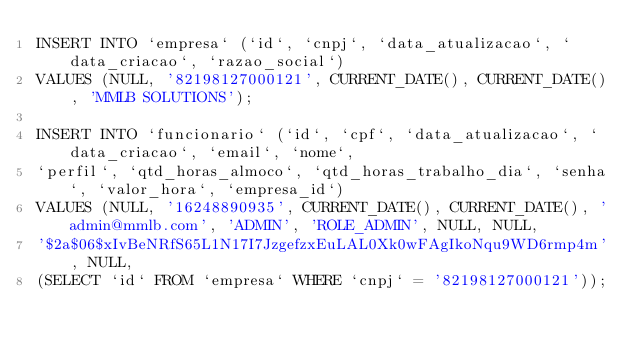<code> <loc_0><loc_0><loc_500><loc_500><_SQL_>INSERT INTO `empresa` (`id`, `cnpj`, `data_atualizacao`, `data_criacao`, `razao_social`) 
VALUES (NULL, '82198127000121', CURRENT_DATE(), CURRENT_DATE(), 'MMLB SOLUTIONS');

INSERT INTO `funcionario` (`id`, `cpf`, `data_atualizacao`, `data_criacao`, `email`, `nome`, 
`perfil`, `qtd_horas_almoco`, `qtd_horas_trabalho_dia`, `senha`, `valor_hora`, `empresa_id`) 
VALUES (NULL, '16248890935', CURRENT_DATE(), CURRENT_DATE(), 'admin@mmlb.com', 'ADMIN', 'ROLE_ADMIN', NULL, NULL, 
'$2a$06$xIvBeNRfS65L1N17I7JzgefzxEuLAL0Xk0wFAgIkoNqu9WD6rmp4m', NULL, 
(SELECT `id` FROM `empresa` WHERE `cnpj` = '82198127000121'));
</code> 